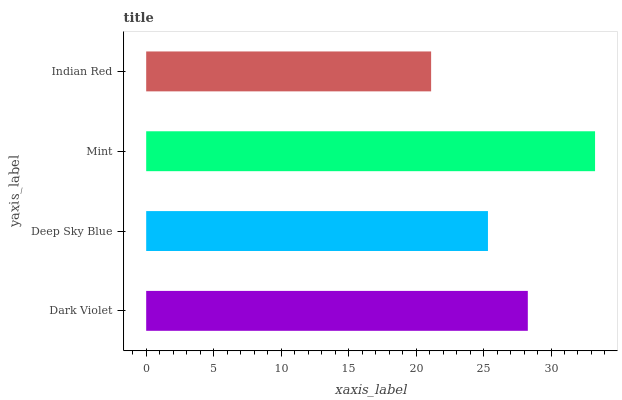Is Indian Red the minimum?
Answer yes or no. Yes. Is Mint the maximum?
Answer yes or no. Yes. Is Deep Sky Blue the minimum?
Answer yes or no. No. Is Deep Sky Blue the maximum?
Answer yes or no. No. Is Dark Violet greater than Deep Sky Blue?
Answer yes or no. Yes. Is Deep Sky Blue less than Dark Violet?
Answer yes or no. Yes. Is Deep Sky Blue greater than Dark Violet?
Answer yes or no. No. Is Dark Violet less than Deep Sky Blue?
Answer yes or no. No. Is Dark Violet the high median?
Answer yes or no. Yes. Is Deep Sky Blue the low median?
Answer yes or no. Yes. Is Deep Sky Blue the high median?
Answer yes or no. No. Is Indian Red the low median?
Answer yes or no. No. 